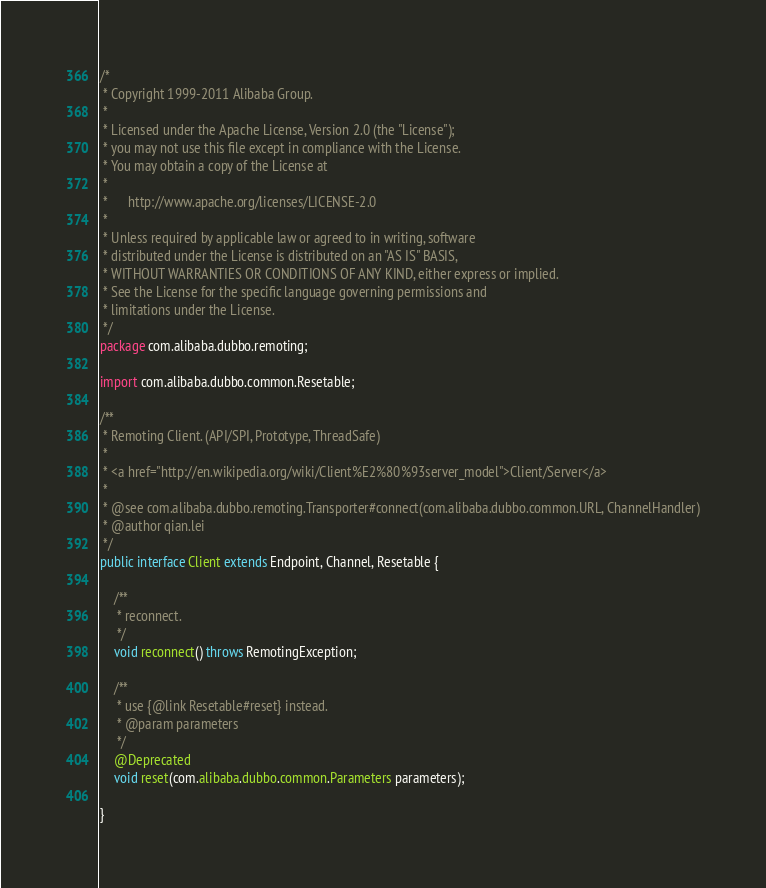<code> <loc_0><loc_0><loc_500><loc_500><_Java_>/*
 * Copyright 1999-2011 Alibaba Group.
 *  
 * Licensed under the Apache License, Version 2.0 (the "License");
 * you may not use this file except in compliance with the License.
 * You may obtain a copy of the License at
 *  
 *      http://www.apache.org/licenses/LICENSE-2.0
 *  
 * Unless required by applicable law or agreed to in writing, software
 * distributed under the License is distributed on an "AS IS" BASIS,
 * WITHOUT WARRANTIES OR CONDITIONS OF ANY KIND, either express or implied.
 * See the License for the specific language governing permissions and
 * limitations under the License.
 */
package com.alibaba.dubbo.remoting;

import com.alibaba.dubbo.common.Resetable;

/**
 * Remoting Client. (API/SPI, Prototype, ThreadSafe)
 * 
 * <a href="http://en.wikipedia.org/wiki/Client%E2%80%93server_model">Client/Server</a>
 * 
 * @see com.alibaba.dubbo.remoting.Transporter#connect(com.alibaba.dubbo.common.URL, ChannelHandler)
 * @author qian.lei
 */
public interface Client extends Endpoint, Channel, Resetable {

    /**
     * reconnect.
     */
    void reconnect() throws RemotingException;

    /**
     * use {@link Resetable#reset} instead.
     * @param parameters
     */
    @Deprecated
    void reset(com.alibaba.dubbo.common.Parameters parameters);
    
}</code> 